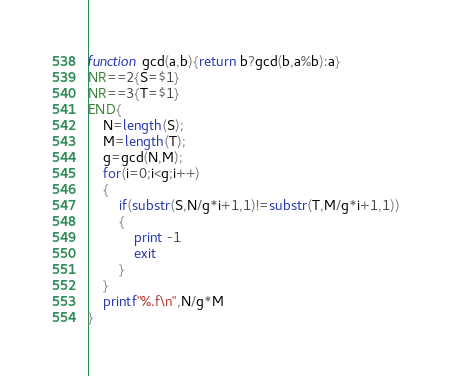Convert code to text. <code><loc_0><loc_0><loc_500><loc_500><_Awk_>function gcd(a,b){return b?gcd(b,a%b):a}
NR==2{S=$1}
NR==3{T=$1}
END{
	N=length(S);
	M=length(T);
	g=gcd(N,M);
	for(i=0;i<g;i++)
	{
		if(substr(S,N/g*i+1,1)!=substr(T,M/g*i+1,1))
		{
			print -1
			exit
		}
	}
	printf"%.f\n",N/g*M
}
</code> 